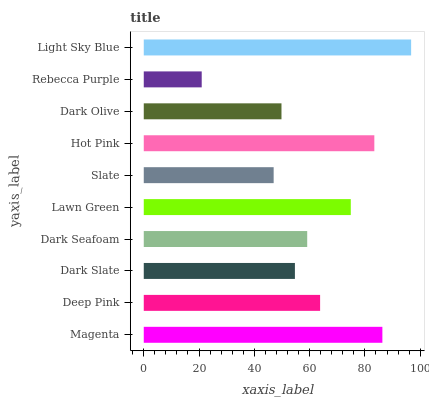Is Rebecca Purple the minimum?
Answer yes or no. Yes. Is Light Sky Blue the maximum?
Answer yes or no. Yes. Is Deep Pink the minimum?
Answer yes or no. No. Is Deep Pink the maximum?
Answer yes or no. No. Is Magenta greater than Deep Pink?
Answer yes or no. Yes. Is Deep Pink less than Magenta?
Answer yes or no. Yes. Is Deep Pink greater than Magenta?
Answer yes or no. No. Is Magenta less than Deep Pink?
Answer yes or no. No. Is Deep Pink the high median?
Answer yes or no. Yes. Is Dark Seafoam the low median?
Answer yes or no. Yes. Is Light Sky Blue the high median?
Answer yes or no. No. Is Dark Olive the low median?
Answer yes or no. No. 